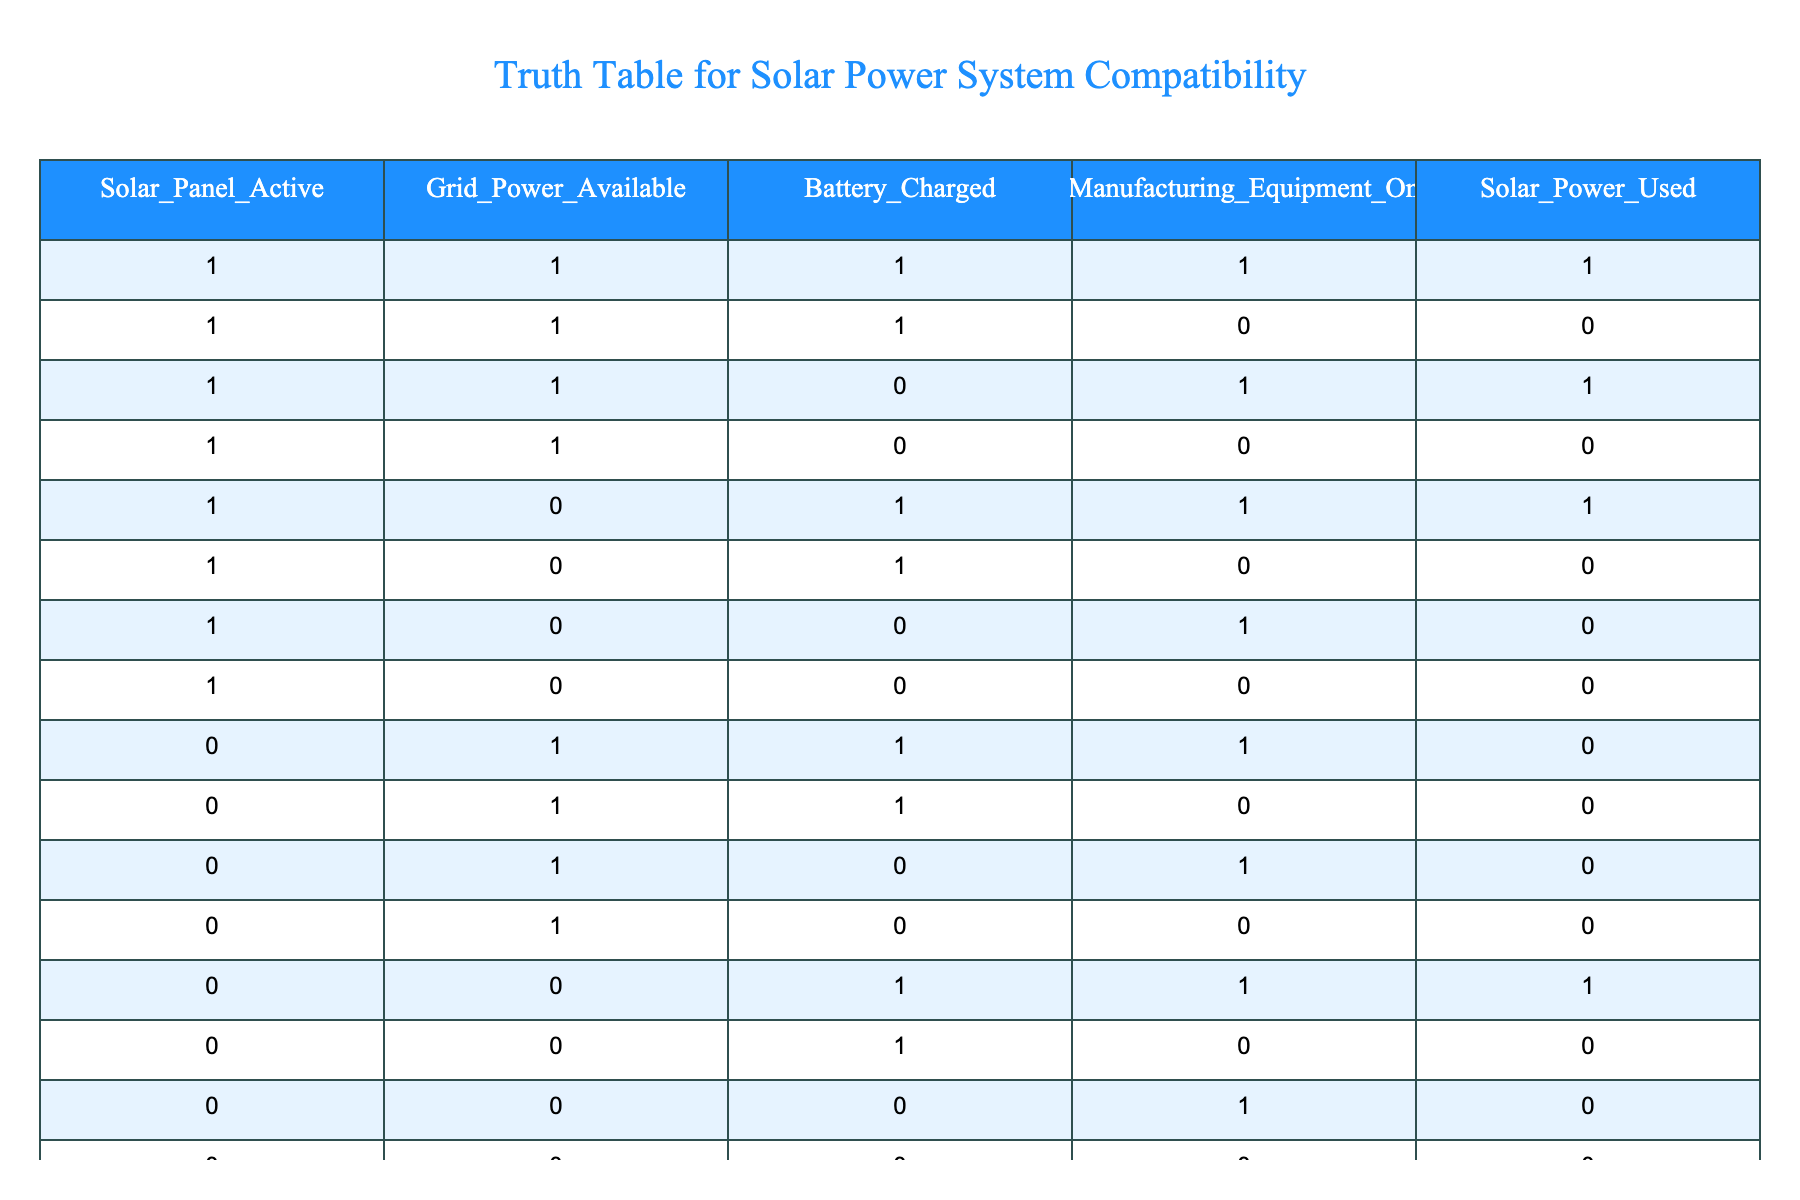What is the count of scenarios where solar power is used? To find the count, I will look for the rows where the "Solar_Power_Used" column has a value of 1. There are 5 scenarios with solar power used in the table.
Answer: 5 In how many instances is the manufacturing equipment on while solar power is also being used? I will identify rows where both "Manufacturing_Equipment_On" and "Solar_Power_Used" are 1. This occurs in 3 instances.
Answer: 3 Is there a case where the solar panel is active, and the grid power is unavailable while the battery is charged? I will check the row with solar panel active (1), grid power available (0), and battery charged (1). This is true in one scenario from the table.
Answer: Yes What proportion of total scenarios have solar power being utilized when the grid power is available? First, I identify scenarios with grid power available (which is columns with a 1 under "Grid_Power_Available"). Out of 8 such rows, solar power is used in 4 of them, giving a proportion of 4/8 = 1/2.
Answer: 0.5 How many instances have battery charged, grid power available, and manufacturing equipment off? By examining the rows where "Battery_Charged" equals 1, "Grid_Power_Available" equals 1, and "Manufacturing_Equipment_On" equals 0, I find there are 2 instances meeting these criteria.
Answer: 2 Is there a row where the battery is not charged, but the manufacturing equipment is operational? I'll look at the rows where "Battery_Charged" equals 0 and "Manufacturing_Equipment_On" equals 1. According to the table, there are no rows that meet this condition.
Answer: No What is the total number of instances where solar power is not used? I will count the rows where "Solar_Power_Used" equals 0. There are 8 instances in the table where solar power is not utilized.
Answer: 8 How many total combinations have solar panels active and the manufacturing equipment off? I will filter to find rows with "Solar_Panel_Active" as 1 and "Manufacturing_Equipment_On" as 0. I find 3 such combinations from the table.
Answer: 3 